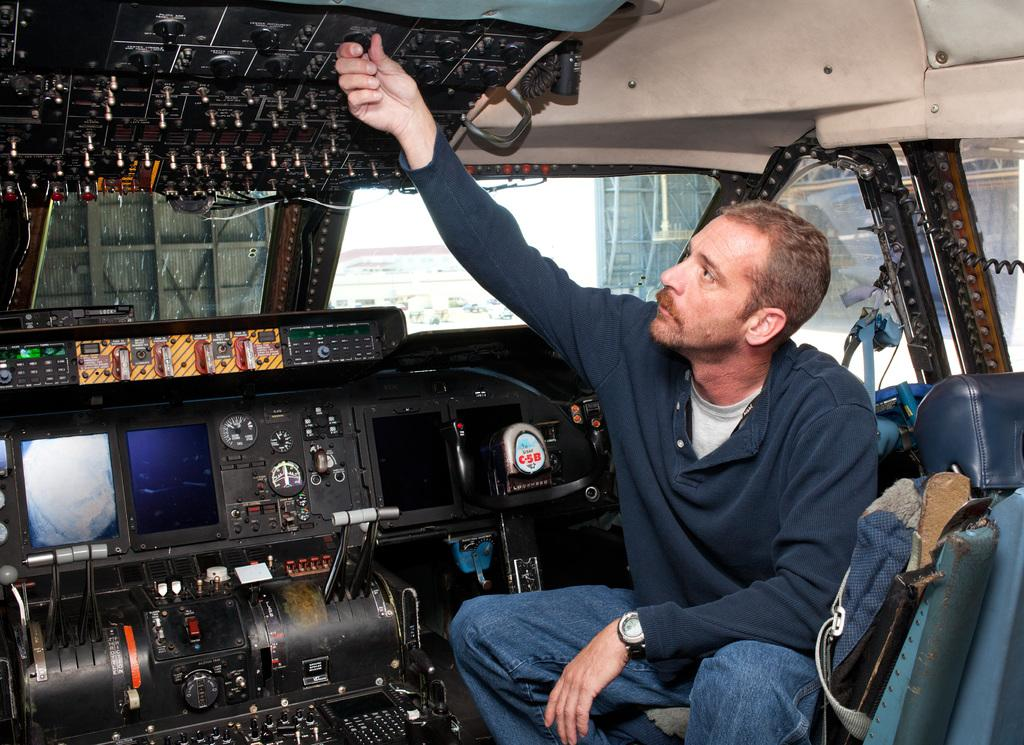What is the person in the image doing? The person is sitting inside a vehicle. What feature of the vehicle is mentioned in the facts? The vehicle has a glass window. What can be seen through the glass window of the vehicle? There is a fence visible behind the glass window of the vehicle. What type of hat is the bat wearing in the image? There is no bat or hat present in the image. 